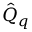Convert formula to latex. <formula><loc_0><loc_0><loc_500><loc_500>\hat { Q } _ { q }</formula> 